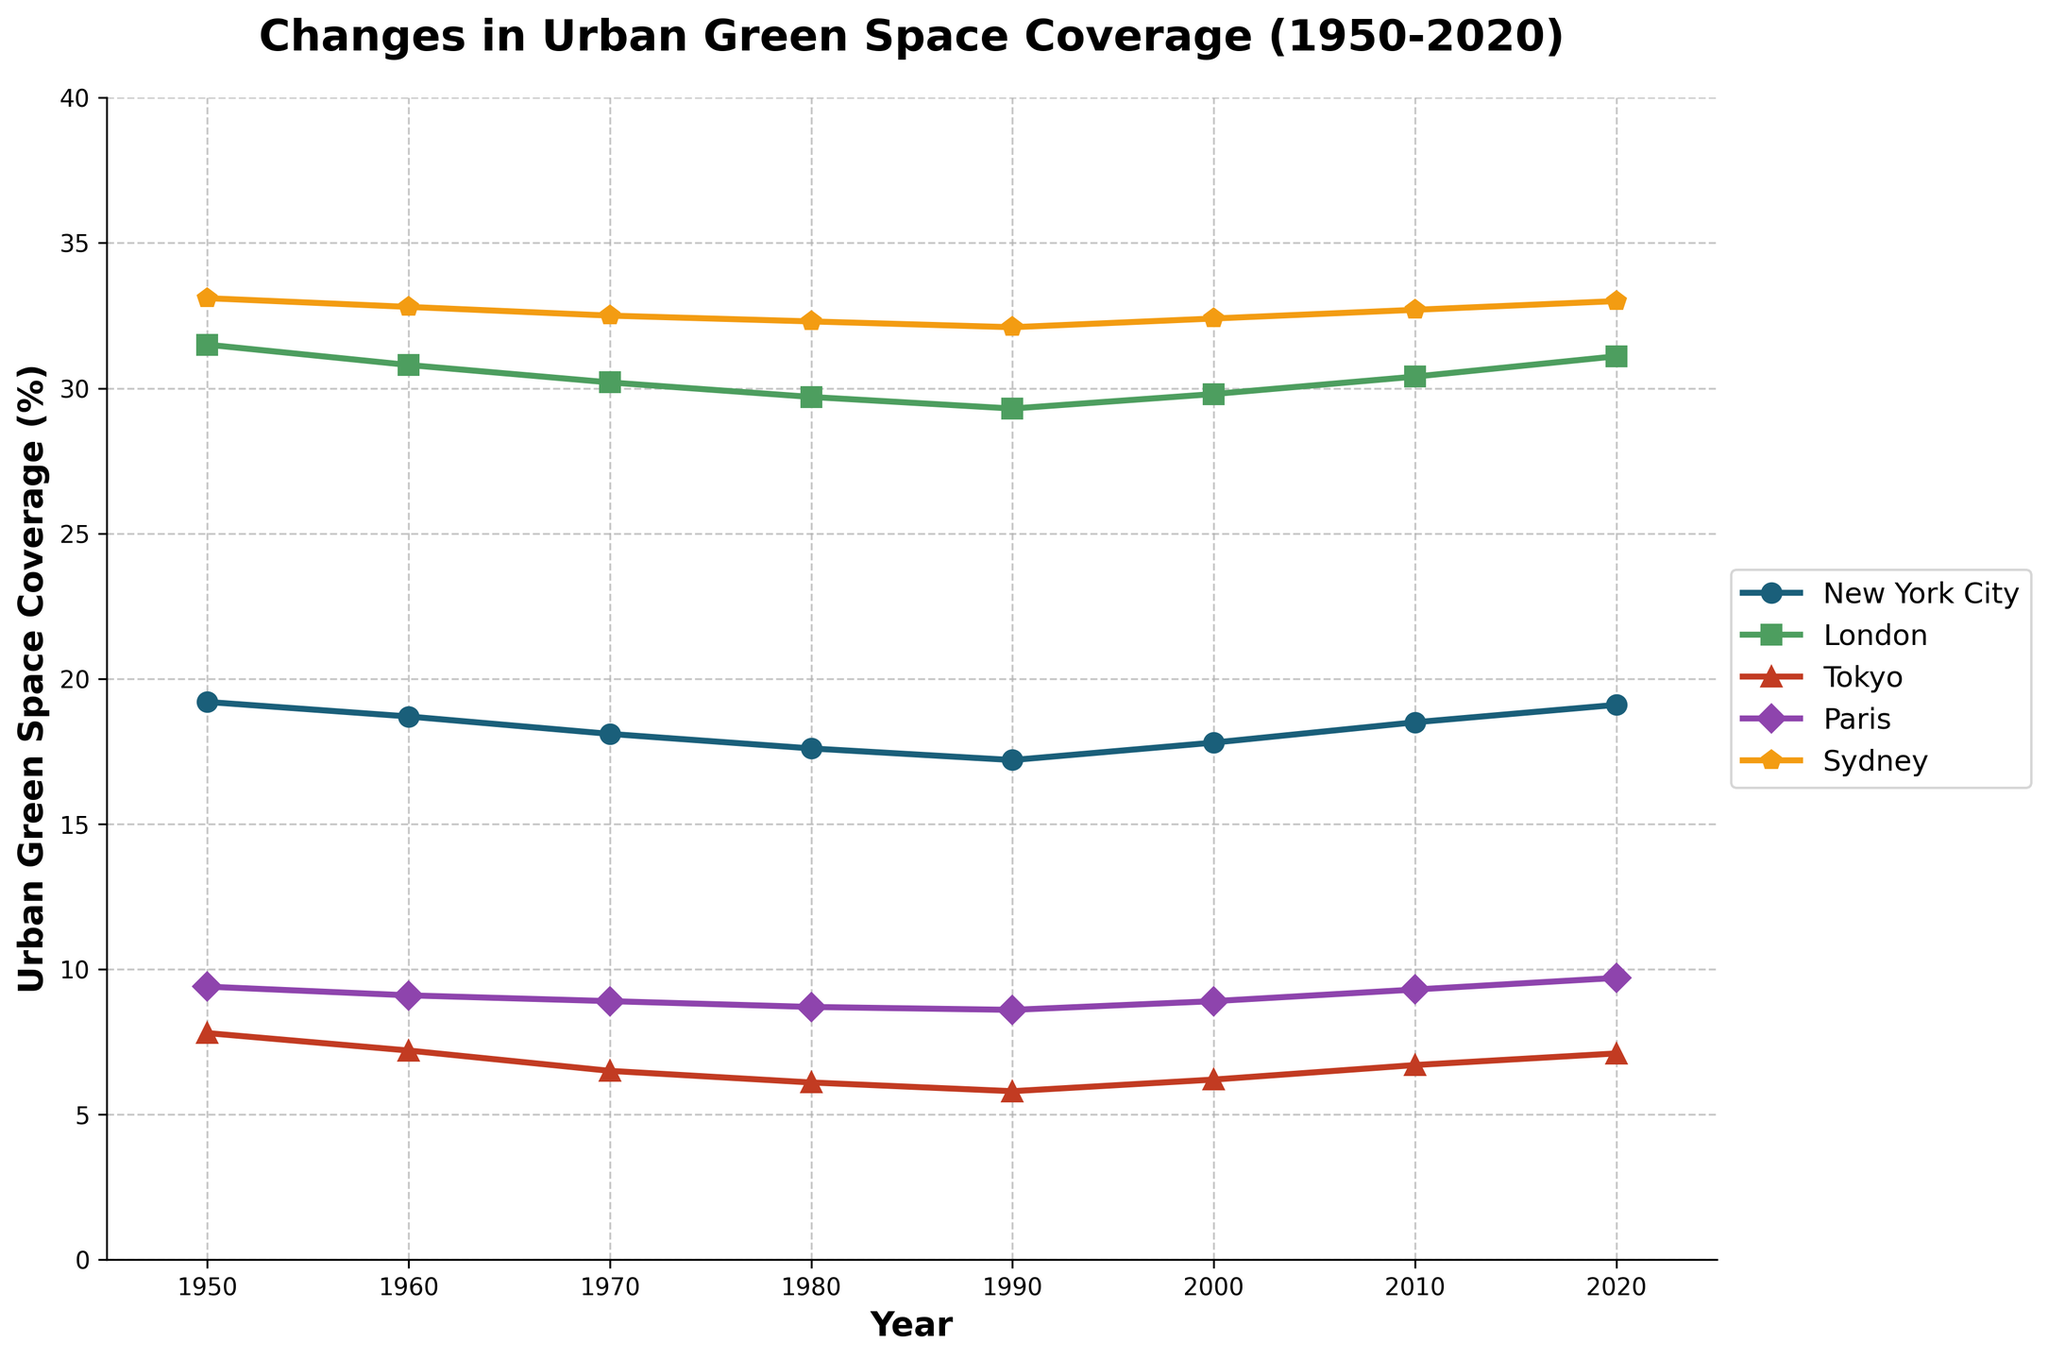What city had the highest urban green space coverage in 1950? From the line chart, we see that Sydney had the highest green space coverage in 1950 with over 33.1%.
Answer: Sydney Which two cities showed an increase in urban green space coverage from 2000 to 2020? By observing the lines for each city, we can see that New York City and Paris experienced an increase in their green space coverage from 2000 to 2020.
Answer: New York City and Paris What was the change in urban green space coverage for Tokyo between 1950 and 1990? Tokyo's green space coverage decreased from 7.8% in 1950 to 5.8% in 1990. The change is 7.8 - 5.8 = 2%.
Answer: 2% Which city experienced the most consistent decrease in urban green space coverage from 1950 to 1990? By examining the slopes of the lines, London shows a consistent decrease from 31.5% in 1950 to 29.3% in 1990.
Answer: London What was the average urban green space coverage for Paris from 1950 to 2020? By summing Paris's data points (9.4 + 9.1 + 8.9 + 8.7 + 8.6 + 8.9 + 9.3 + 9.7) and dividing by the number of points (8), we get (72.6 / 8) = 9.1%.
Answer: 9.1% In which decade did New York City see the lowest urban green space coverage? By following New York City's line, the lowest green space coverage occurred in 1990 with a value of 17.2%.
Answer: 1990 How does the green space coverage of Sydney in 1980 compare to that of Tokyo in 2020? Sydney had around 32.3% green space coverage in 1980, while Tokyo had 7.1% in 2020. Sydney's coverage was significantly higher.
Answer: Sydney had significantly higher green space coverage Which city's green space coverage returned to near its original 1950 level by 2020? Observing all lines, New York City's green space coverage in 2020 (19.1%) is very close to its 1950 figure (19.2%).
Answer: New York City What was the average increase in urban green space coverage for Sydney from 2000 to 2020? Sydney's green space coverage increased from 32.4% in 2000 to 33.0% in 2020. The increase is 33.0 - 32.4 = 0.6%.
Answer: 0.6% Which cities had green space coverage values greater than 30% in 2020? Observing the endpoints of the lines in 2020, London and Sydney had green space coverages larger than 30%.
Answer: London and Sydney 